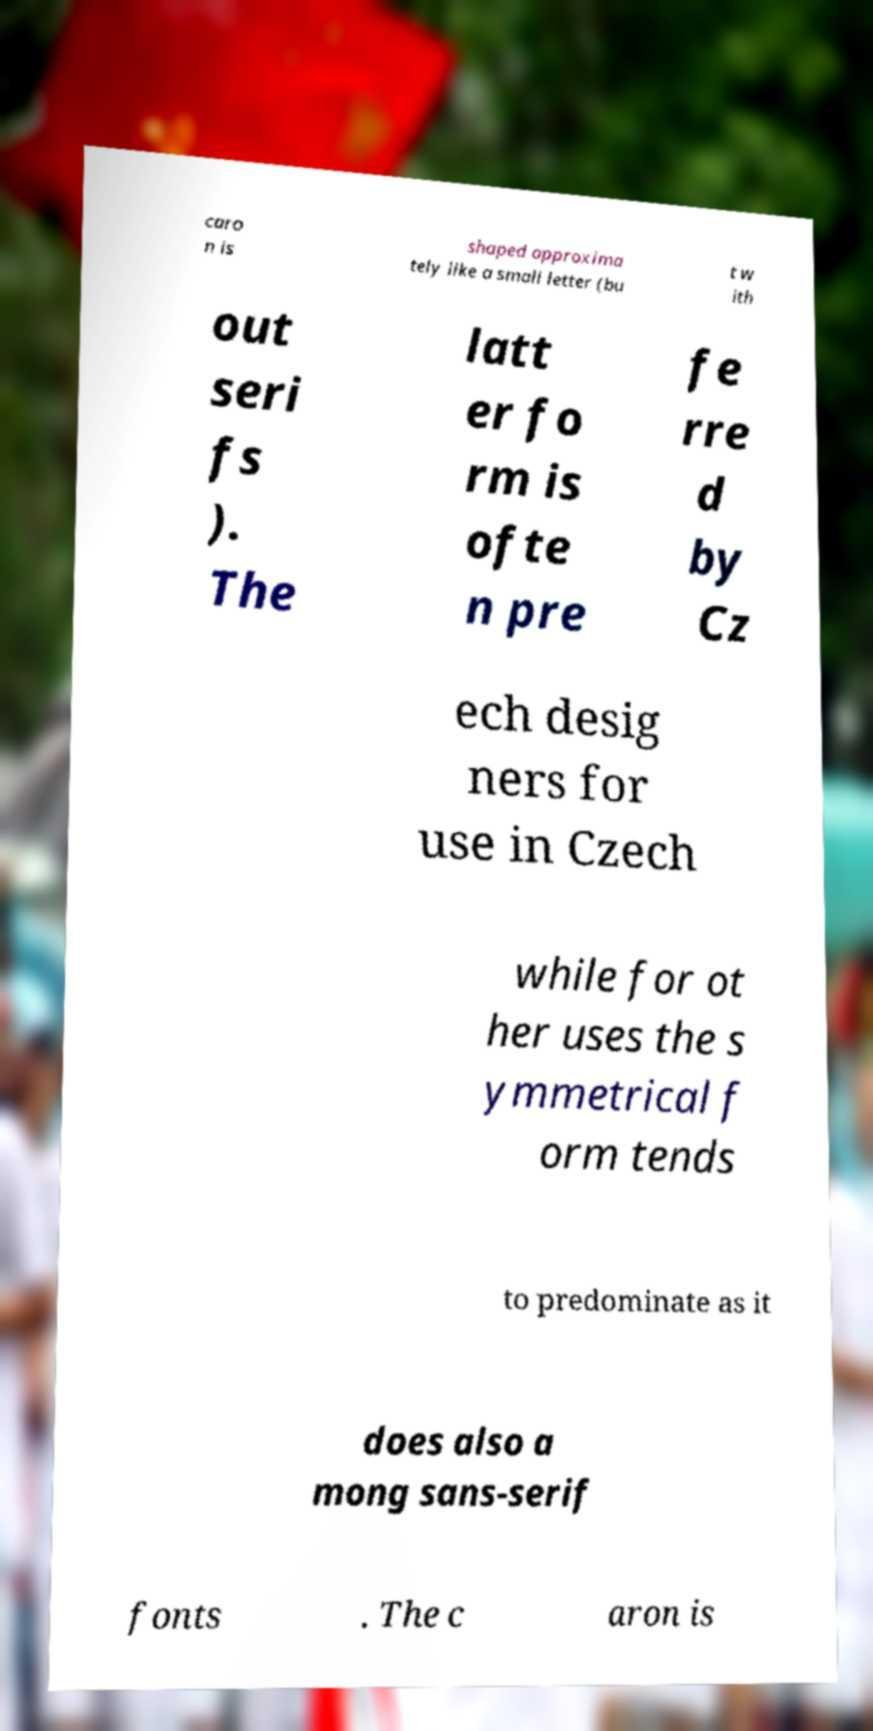What messages or text are displayed in this image? I need them in a readable, typed format. caro n is shaped approxima tely like a small letter (bu t w ith out seri fs ). The latt er fo rm is ofte n pre fe rre d by Cz ech desig ners for use in Czech while for ot her uses the s ymmetrical f orm tends to predominate as it does also a mong sans-serif fonts . The c aron is 